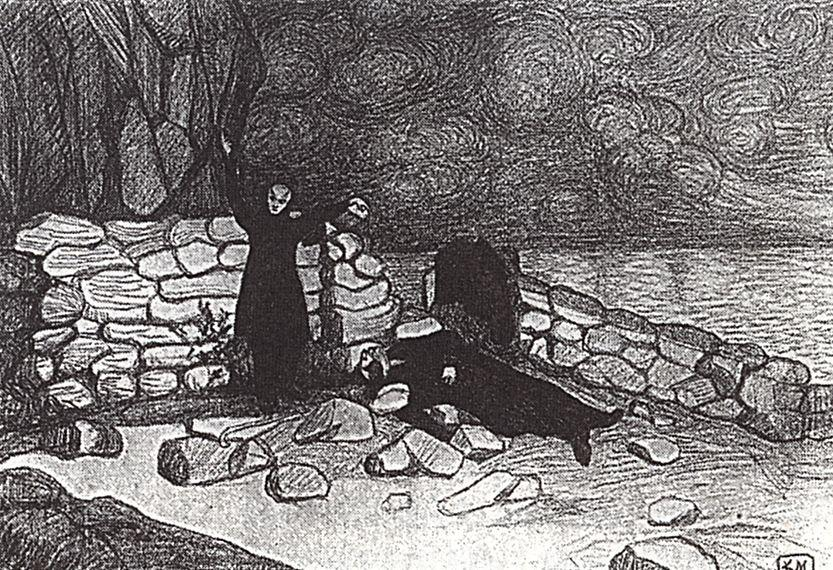What time of day does this scene likely represent, and what mood does it convey? The scene likely represents either early morning or late evening, given the soft ambient light and shadow interplay on the rocks and the building. This timing, along with the swirling clouds in the sky, suggests a mood of introspection and tranquility, possibly tinged with loneliness, as it evokes a sense of being alone with nature, away from the hustle of everyday life. 